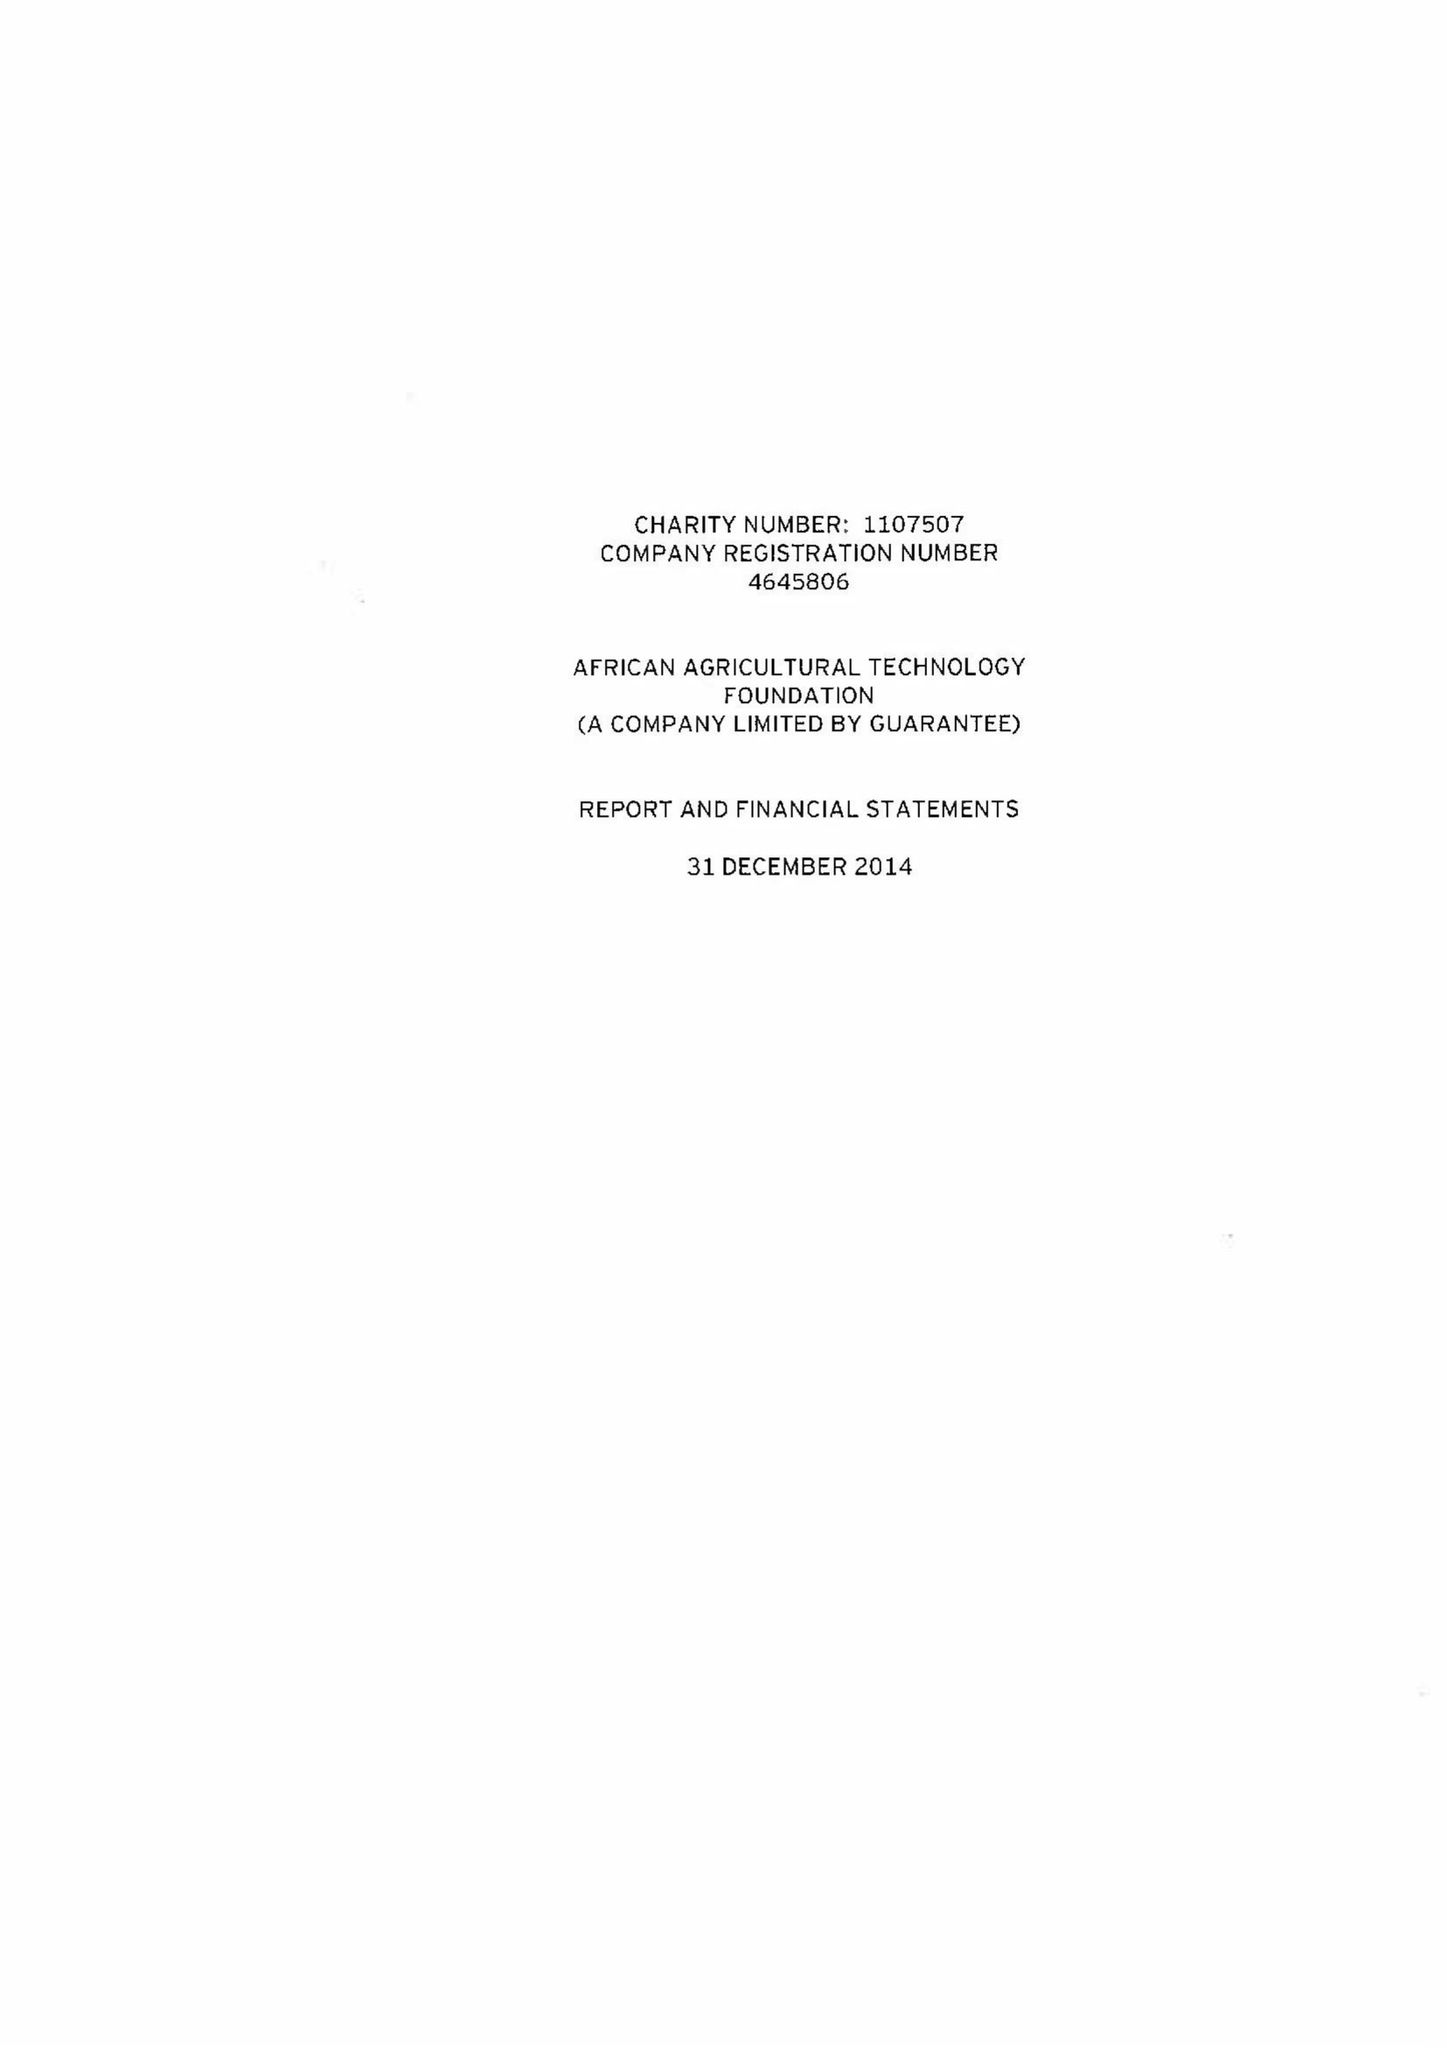What is the value for the report_date?
Answer the question using a single word or phrase. 2014-12-31 